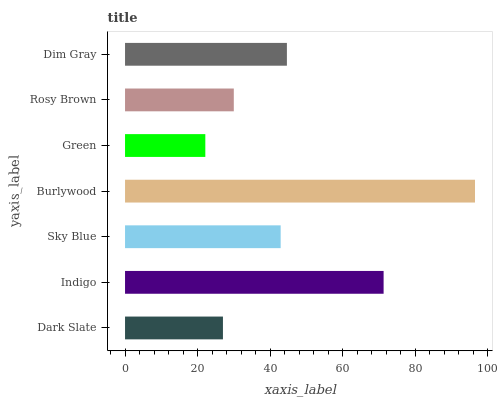Is Green the minimum?
Answer yes or no. Yes. Is Burlywood the maximum?
Answer yes or no. Yes. Is Indigo the minimum?
Answer yes or no. No. Is Indigo the maximum?
Answer yes or no. No. Is Indigo greater than Dark Slate?
Answer yes or no. Yes. Is Dark Slate less than Indigo?
Answer yes or no. Yes. Is Dark Slate greater than Indigo?
Answer yes or no. No. Is Indigo less than Dark Slate?
Answer yes or no. No. Is Sky Blue the high median?
Answer yes or no. Yes. Is Sky Blue the low median?
Answer yes or no. Yes. Is Dim Gray the high median?
Answer yes or no. No. Is Dim Gray the low median?
Answer yes or no. No. 